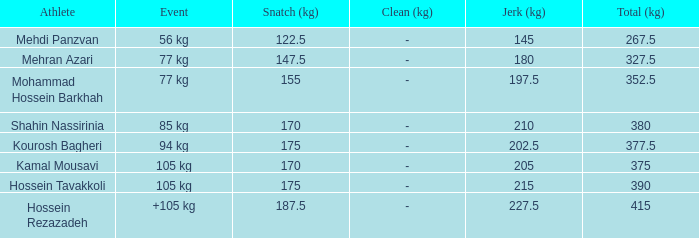Write the full table. {'header': ['Athlete', 'Event', 'Snatch (kg)', 'Clean (kg)', 'Jerk (kg)', 'Total (kg)'], 'rows': [['Mehdi Panzvan', '56 kg', '122.5', '-', '145', '267.5'], ['Mehran Azari', '77 kg', '147.5', '-', '180', '327.5'], ['Mohammad Hossein Barkhah', '77 kg', '155', '-', '197.5', '352.5'], ['Shahin Nassirinia', '85 kg', '170', '-', '210', '380'], ['Kourosh Bagheri', '94 kg', '175', '-', '202.5', '377.5'], ['Kamal Mousavi', '105 kg', '170', '-', '205', '375'], ['Hossein Tavakkoli', '105 kg', '175', '-', '215', '390'], ['Hossein Rezazadeh', '+105 kg', '187.5', '-', '227.5', '415']]} What is the lowest total that had less than 170 snatches, 56 kg events and less than 145 clean & jerk? None. 